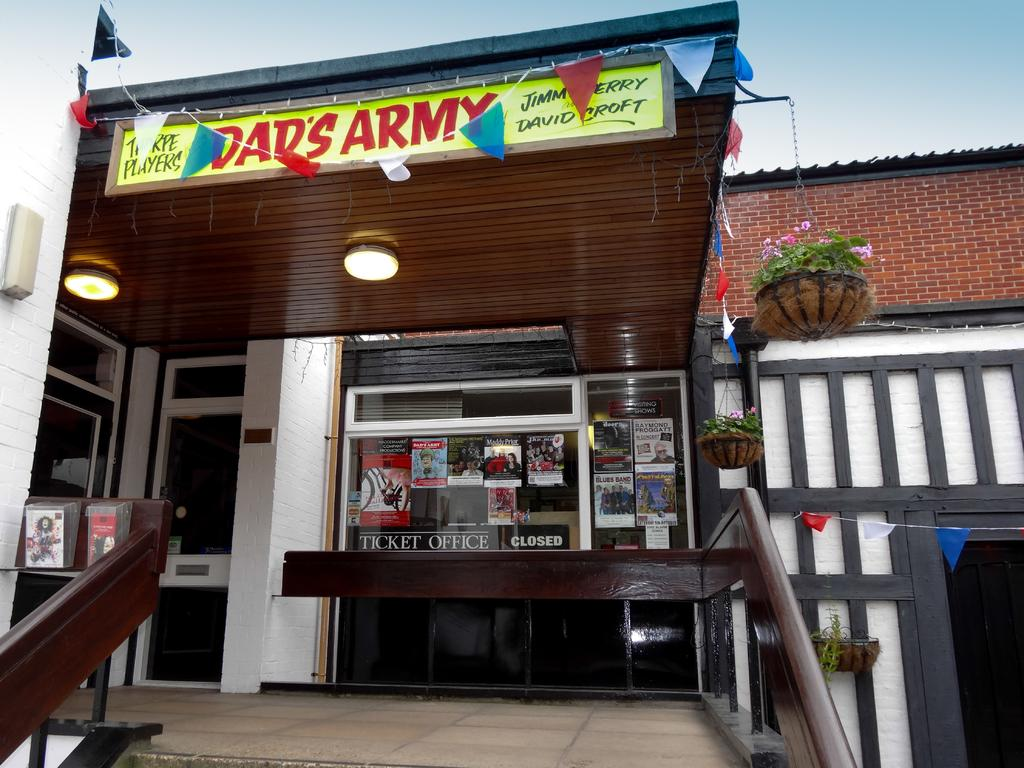<image>
Present a compact description of the photo's key features. A sign for a show called "Dad's Army" sits atop the entrance to a theater box office. 